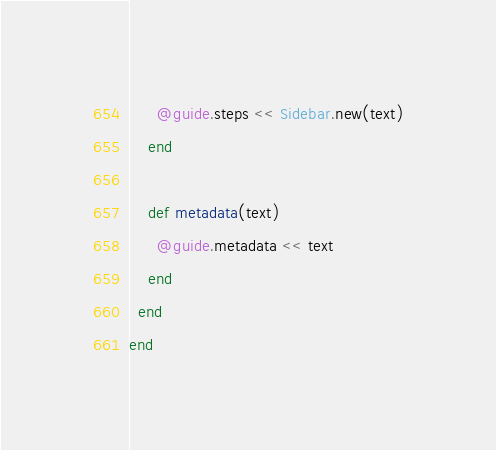Convert code to text. <code><loc_0><loc_0><loc_500><loc_500><_Ruby_>      @guide.steps << Sidebar.new(text)
    end

    def metadata(text)
      @guide.metadata << text
    end
  end
end
</code> 